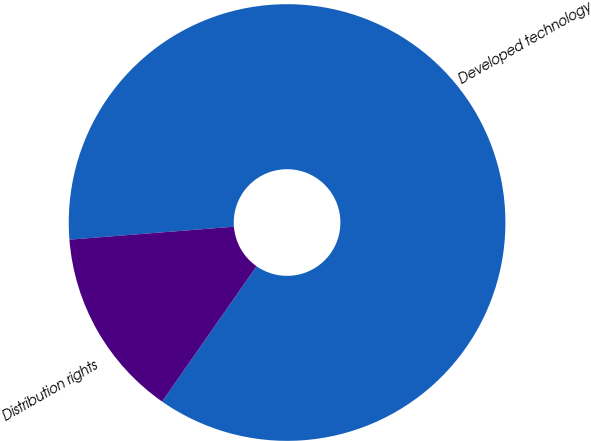<chart> <loc_0><loc_0><loc_500><loc_500><pie_chart><fcel>Developed technology<fcel>Distribution rights<nl><fcel>85.95%<fcel>14.05%<nl></chart> 